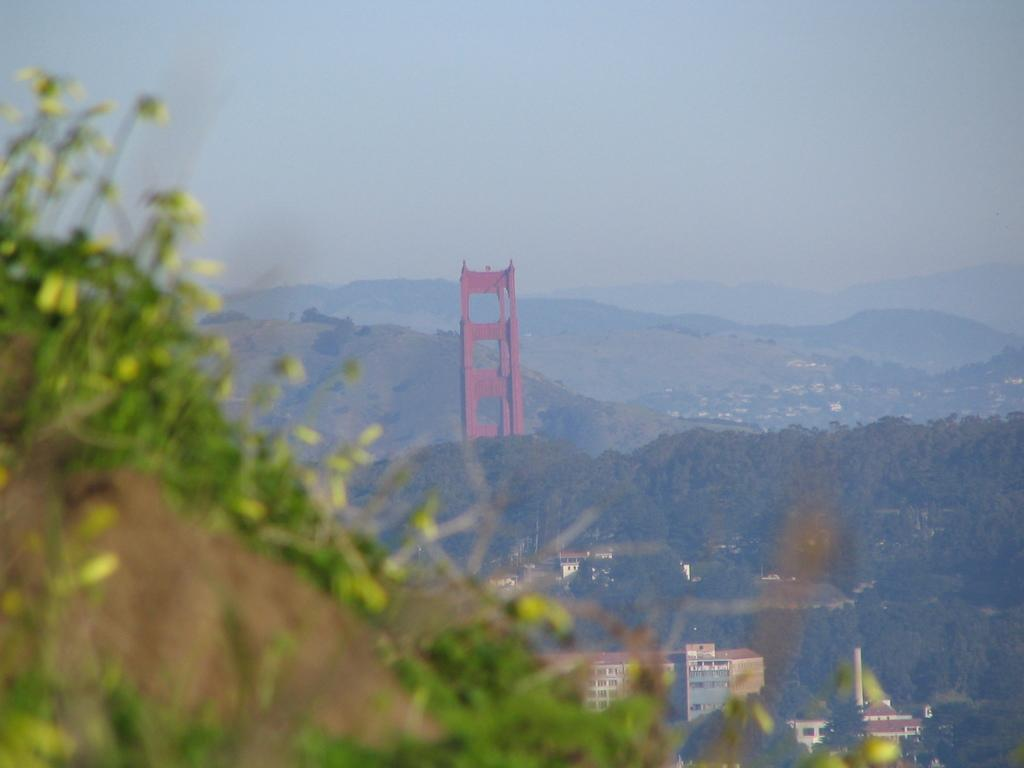What type of natural features can be seen in the image? There are hills in the image. What type of vegetation is present in the image? There are trees and plants in the image. What type of man-made structures can be seen in the image? There are houses and buildings in the image. What is visible in the background of the image? There is a sky visible in the image. What type of gun is being used by the person in the image? There is no person or gun present in the image. What is the distribution of the plants in the image? The distribution of the plants cannot be determined from the image, as it only provides a general view of the area. 